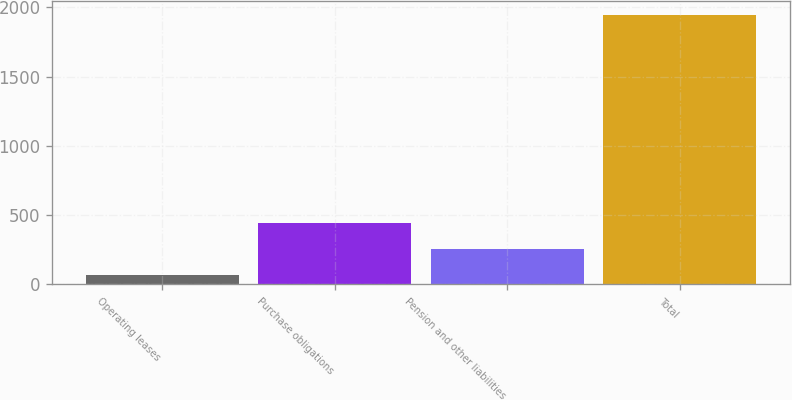Convert chart to OTSL. <chart><loc_0><loc_0><loc_500><loc_500><bar_chart><fcel>Operating leases<fcel>Purchase obligations<fcel>Pension and other liabilities<fcel>Total<nl><fcel>70<fcel>445.6<fcel>257.8<fcel>1948<nl></chart> 